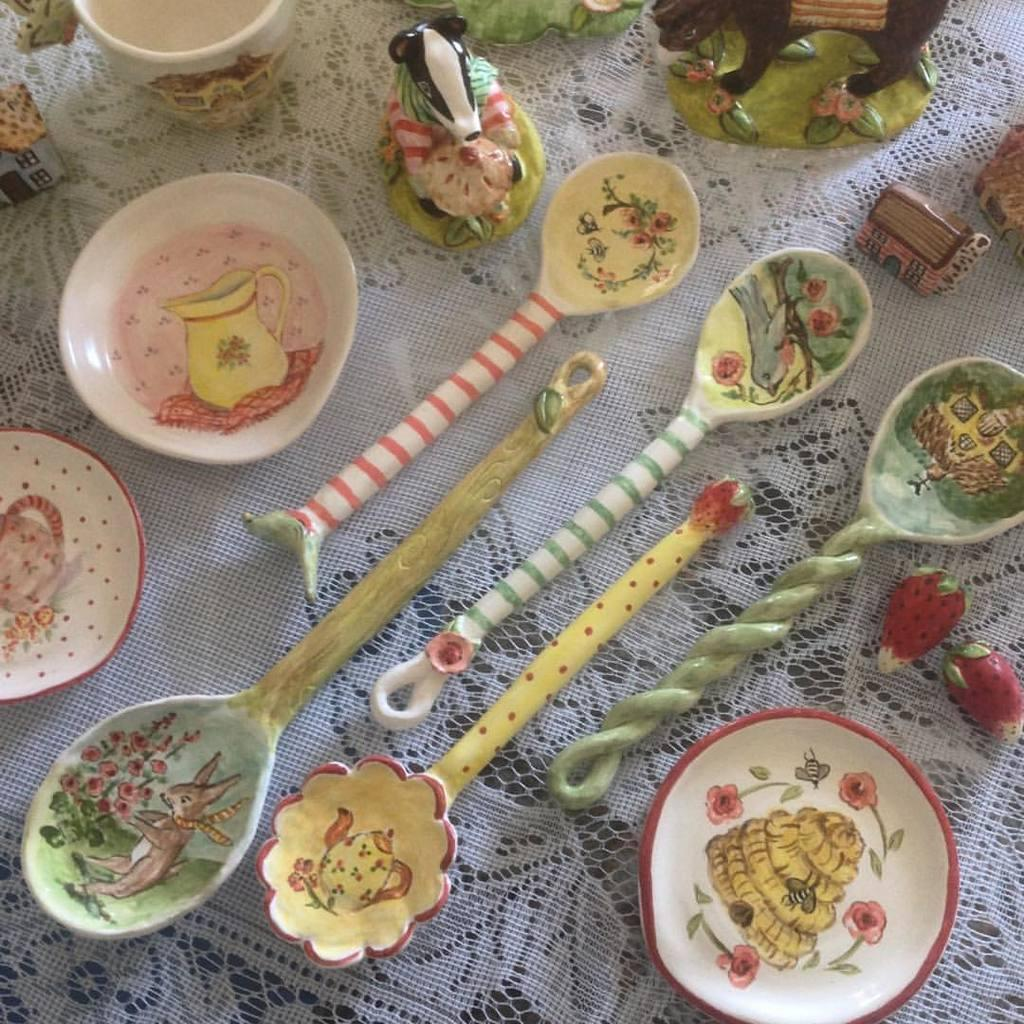What types of objects can be seen in the image? There are colorful objects in the image, including a bowl, a spoon, fruits, toys, and a cup. Can you describe the bowl in the image? The bowl is one of the colorful objects in the image. What else is included in the image besides the bowl? The image also includes a spoon, fruits, toys, and a cup. What type of toy is present in the image? The image includes toys, but the specific type of toy is not mentioned in the facts. Is there a house in the image? Yes, there is a house in the image. How many chickens are sitting on the house in the image? There are no chickens present in the image; it only includes colorful objects, a bowl, a spoon, fruits, toys, and a cup. What type of plant is growing in the bowl in the image? There is no plant growing in the bowl in the image; it contains fruits. 